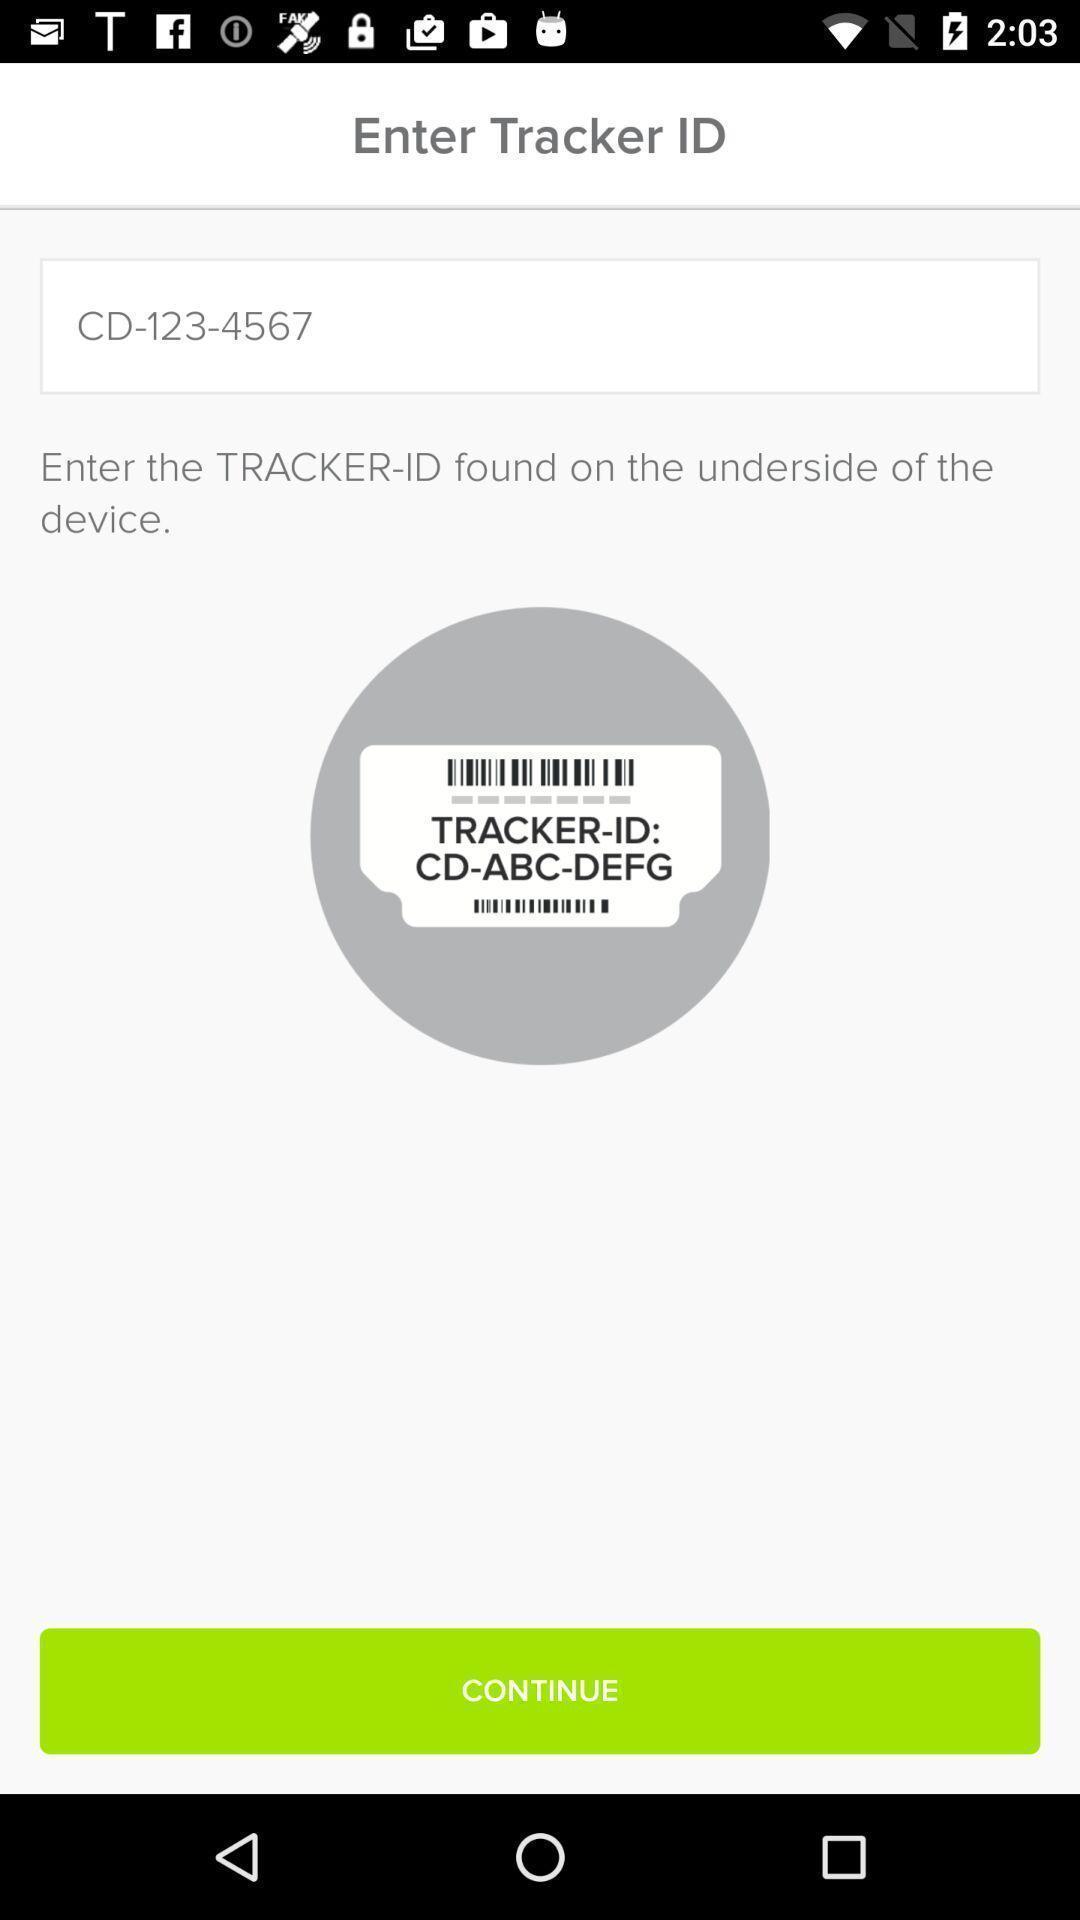Provide a detailed account of this screenshot. Screen asking details to enter track id. 